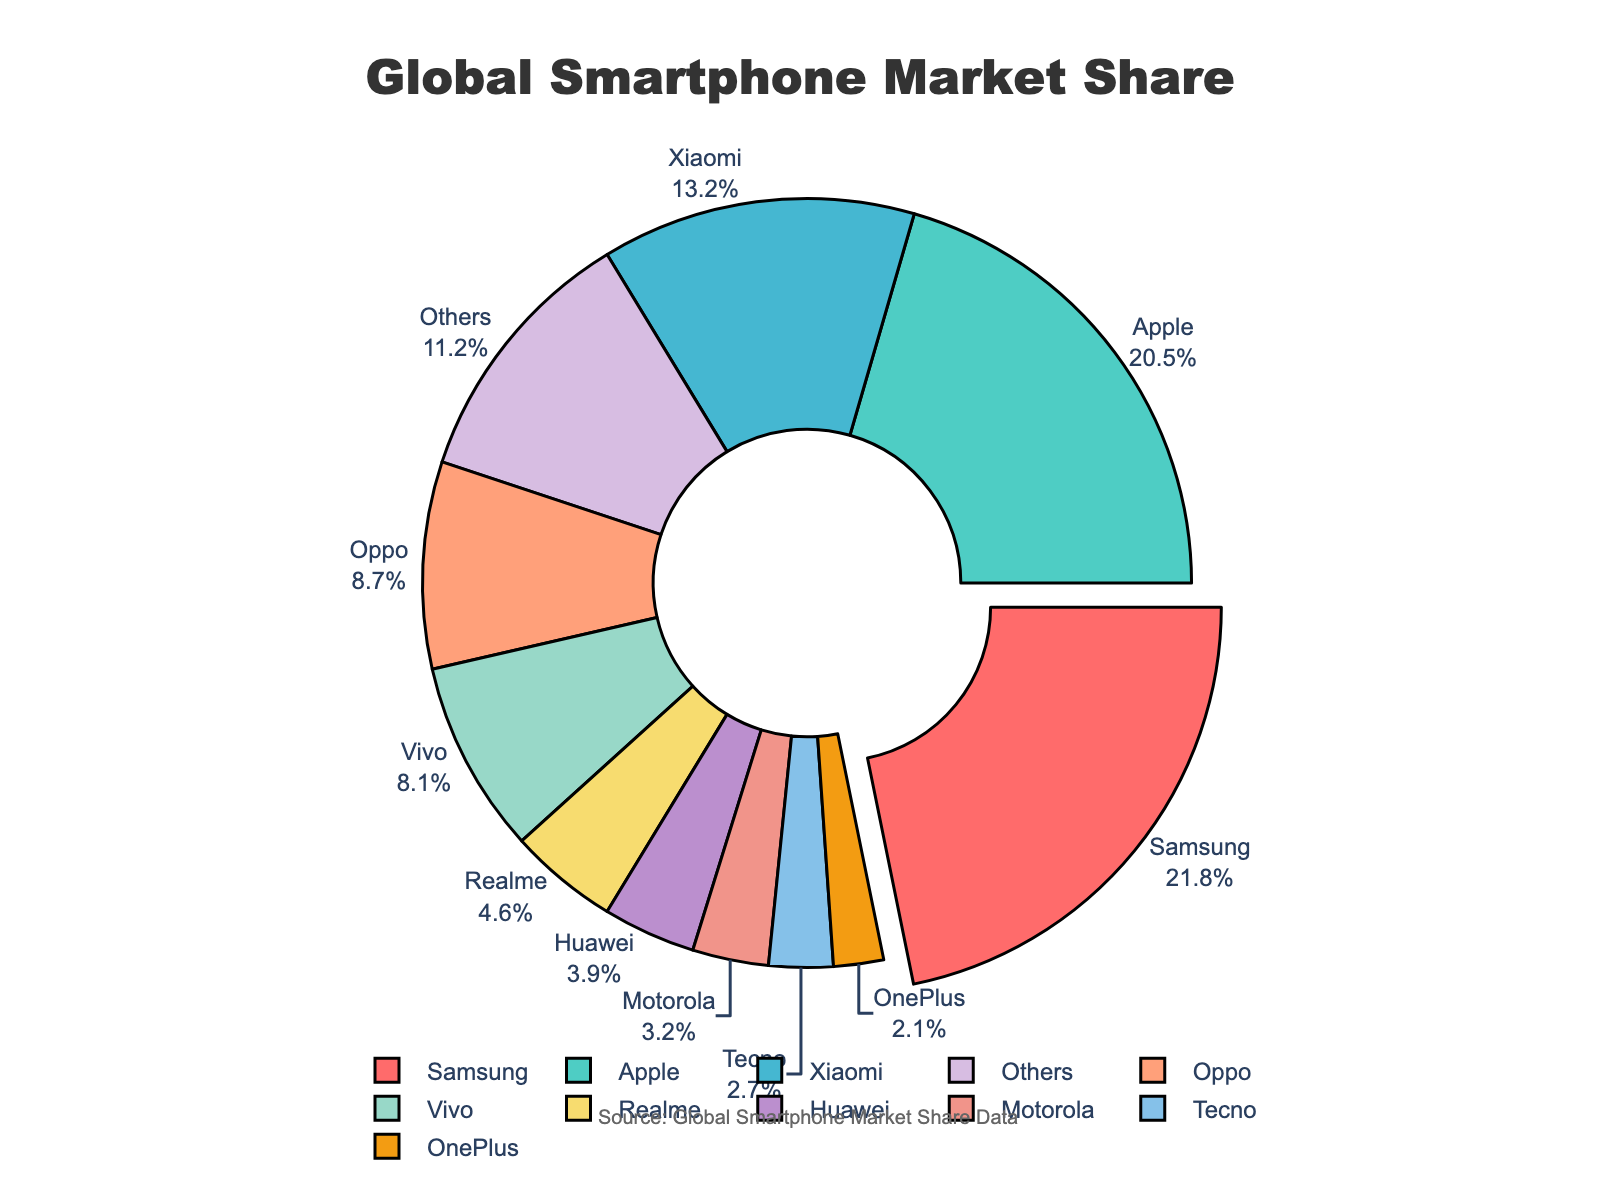Which smartphone brand has the largest market share? The pie chart highlights the largest share by pulling the segment out. The segment pulled out represents Samsung with the highest market share of 21.8%.
Answer: Samsung What is the combined market share of Apple and Xiaomi? Add the market share percentages of Apple (20.5%) and Xiaomi (13.2%) together: 20.5 + 13.2 = 33.7%.
Answer: 33.7% Which brand has a higher market share, Oppo or Vivo? Compare the market shares of Oppo (8.7%) and Vivo (8.1%). Oppo has a higher market share than Vivo.
Answer: Oppo What is the total market share of brands that individually have less than 5% market share? Sum the market shares of Realme (4.6%), Huawei (3.9%), Motorola (3.2%), Tecno (2.7%), and OnePlus (2.1%): 4.6 + 3.9 + 3.2 + 2.7 + 2.1 = 16.5%.
Answer: 16.5% How much more market share does Samsung have compared to Realme? Subtract Realme's market share (4.6%) from Samsung's market share (21.8%): 21.8 - 4.6 = 17.2%.
Answer: 17.2% Which brand is represented by the segment in light blue? Identify the segment colored in light blue, which corresponds to Apple with a 20.5% market share.
Answer: Apple What is the average market share of the top three brands? Sum the market shares of Samsung (21.8%), Apple (20.5%), and Xiaomi (13.2%) and then divide by 3: (21.8 + 20.5 + 13.2) / 3 = 55.5 / 3 = 18.5%.
Answer: 18.5% Which brand among Samsung, Apple, and Xiaomi, has the closest market share to Vivo? Compare Vivo's market share (8.1%) with the market shares of Samsung (21.8%), Apple (20.5%), and Xiaomi (13.2%) to find that Xiaomi (13.2%) is closest.
Answer: Xiaomi What visual feature is used to highlight the brand with the largest market share? The pie chart uses a pulling out effect to highlight the segment representing the brand with the largest market share, which is Samsung.
Answer: Pulling out the segment Which brands have more than 10% market share? The pie chart shows that Samsung (21.8%), Apple (20.5%), and Xiaomi (13.2%) have more than 10% market share.
Answer: Samsung, Apple, Xiaomi 